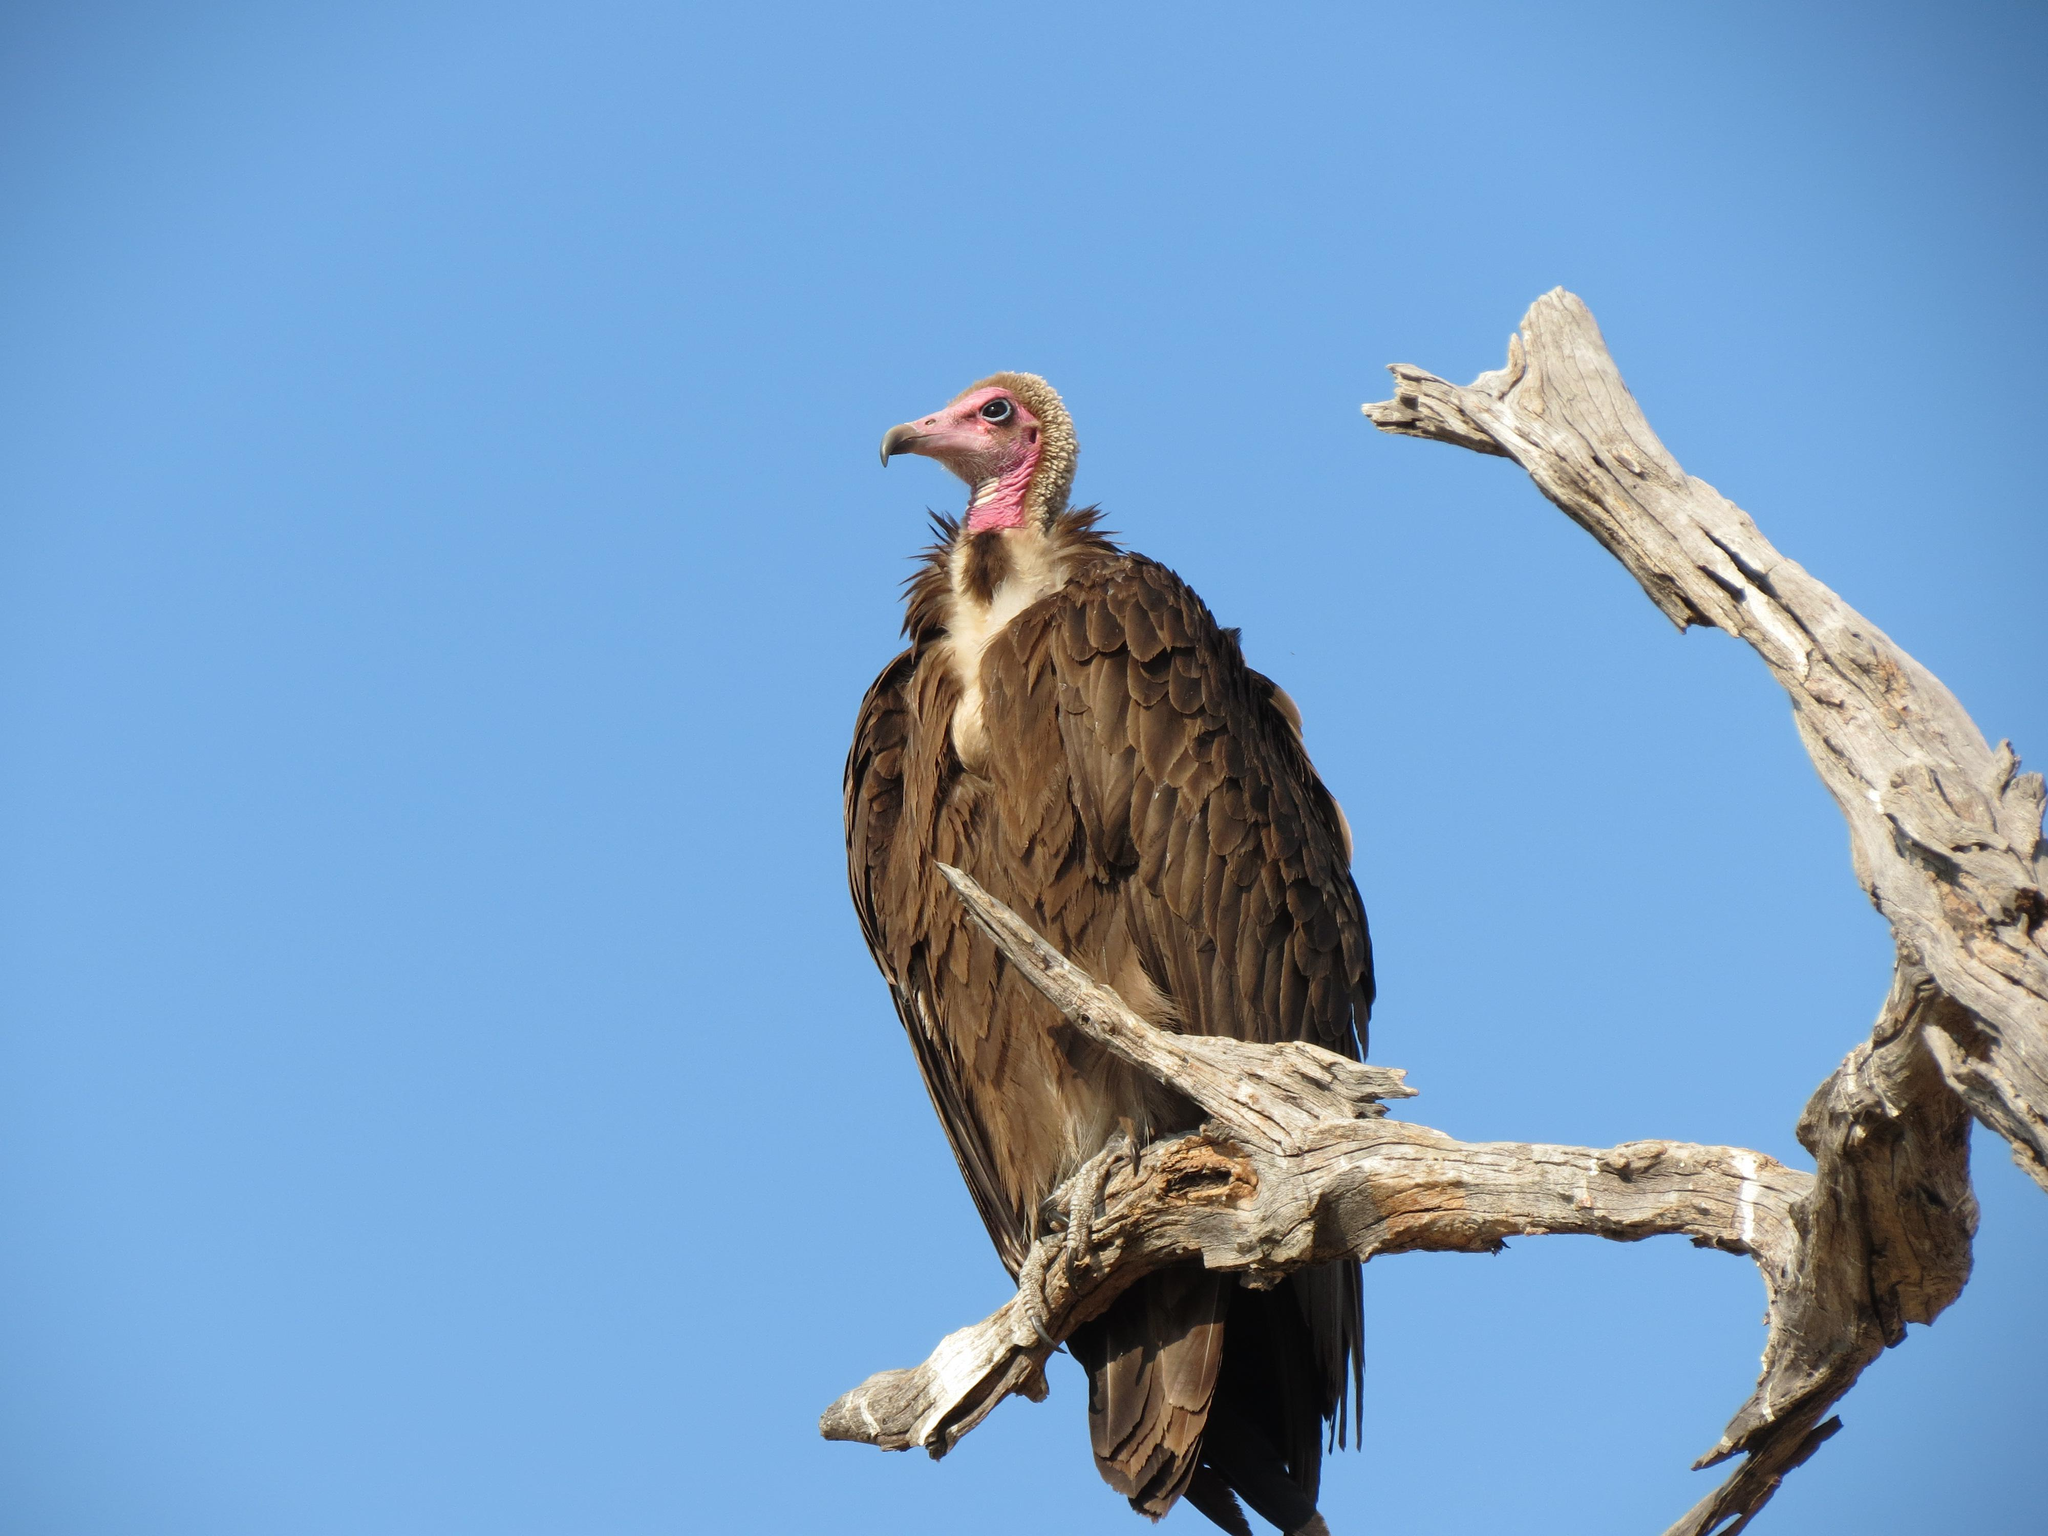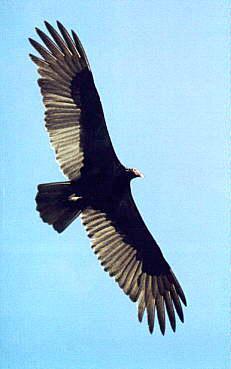The first image is the image on the left, the second image is the image on the right. For the images shown, is this caption "A vulture is sitting on a branch of dead wood with segments that extend up beside its body." true? Answer yes or no. Yes. 